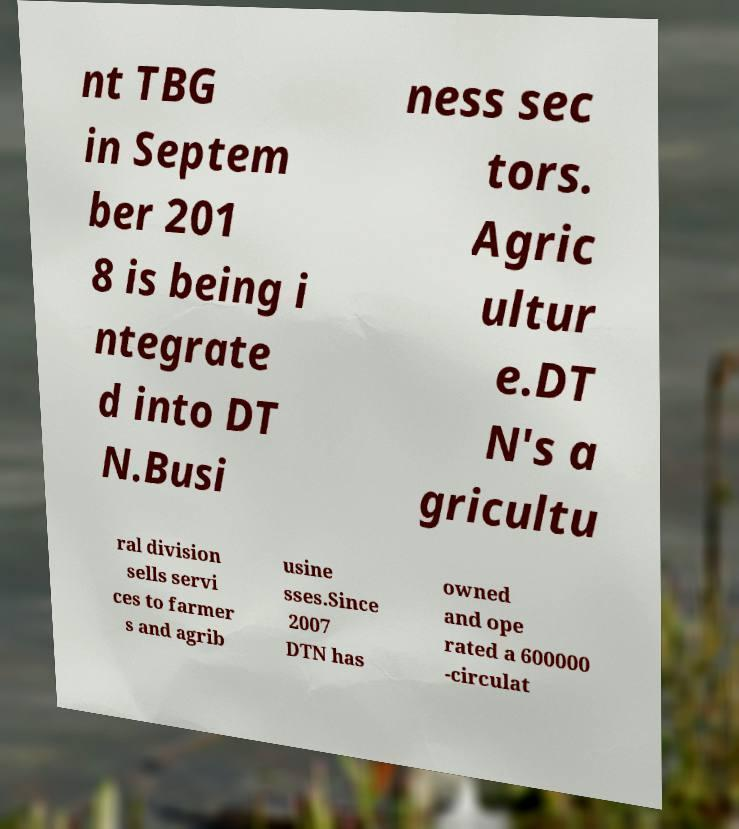Can you read and provide the text displayed in the image?This photo seems to have some interesting text. Can you extract and type it out for me? nt TBG in Septem ber 201 8 is being i ntegrate d into DT N.Busi ness sec tors. Agric ultur e.DT N's a gricultu ral division sells servi ces to farmer s and agrib usine sses.Since 2007 DTN has owned and ope rated a 600000 -circulat 